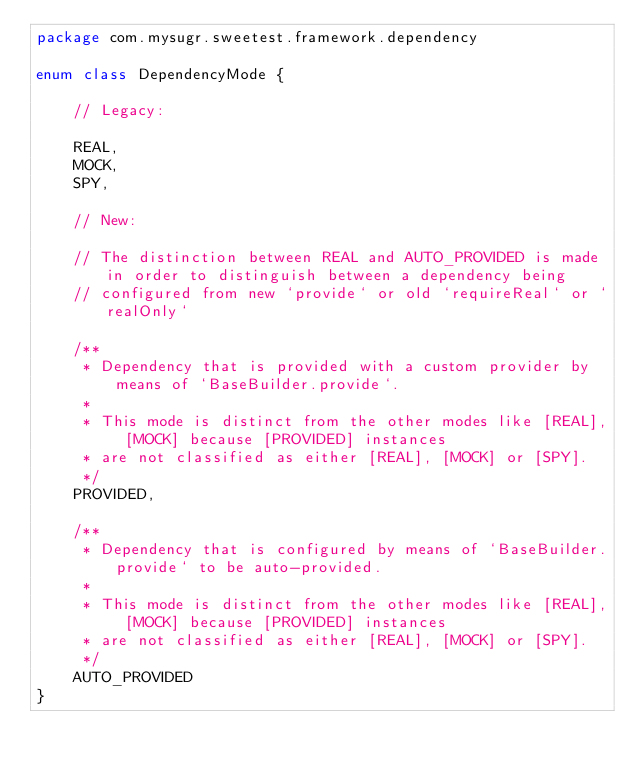<code> <loc_0><loc_0><loc_500><loc_500><_Kotlin_>package com.mysugr.sweetest.framework.dependency

enum class DependencyMode {

    // Legacy:

    REAL,
    MOCK,
    SPY,

    // New:

    // The distinction between REAL and AUTO_PROVIDED is made in order to distinguish between a dependency being
    // configured from new `provide` or old `requireReal` or `realOnly`

    /**
     * Dependency that is provided with a custom provider by means of `BaseBuilder.provide`.
     *
     * This mode is distinct from the other modes like [REAL], [MOCK] because [PROVIDED] instances
     * are not classified as either [REAL], [MOCK] or [SPY].
     */
    PROVIDED,

    /**
     * Dependency that is configured by means of `BaseBuilder.provide` to be auto-provided.
     *
     * This mode is distinct from the other modes like [REAL], [MOCK] because [PROVIDED] instances
     * are not classified as either [REAL], [MOCK] or [SPY].
     */
    AUTO_PROVIDED
}
</code> 